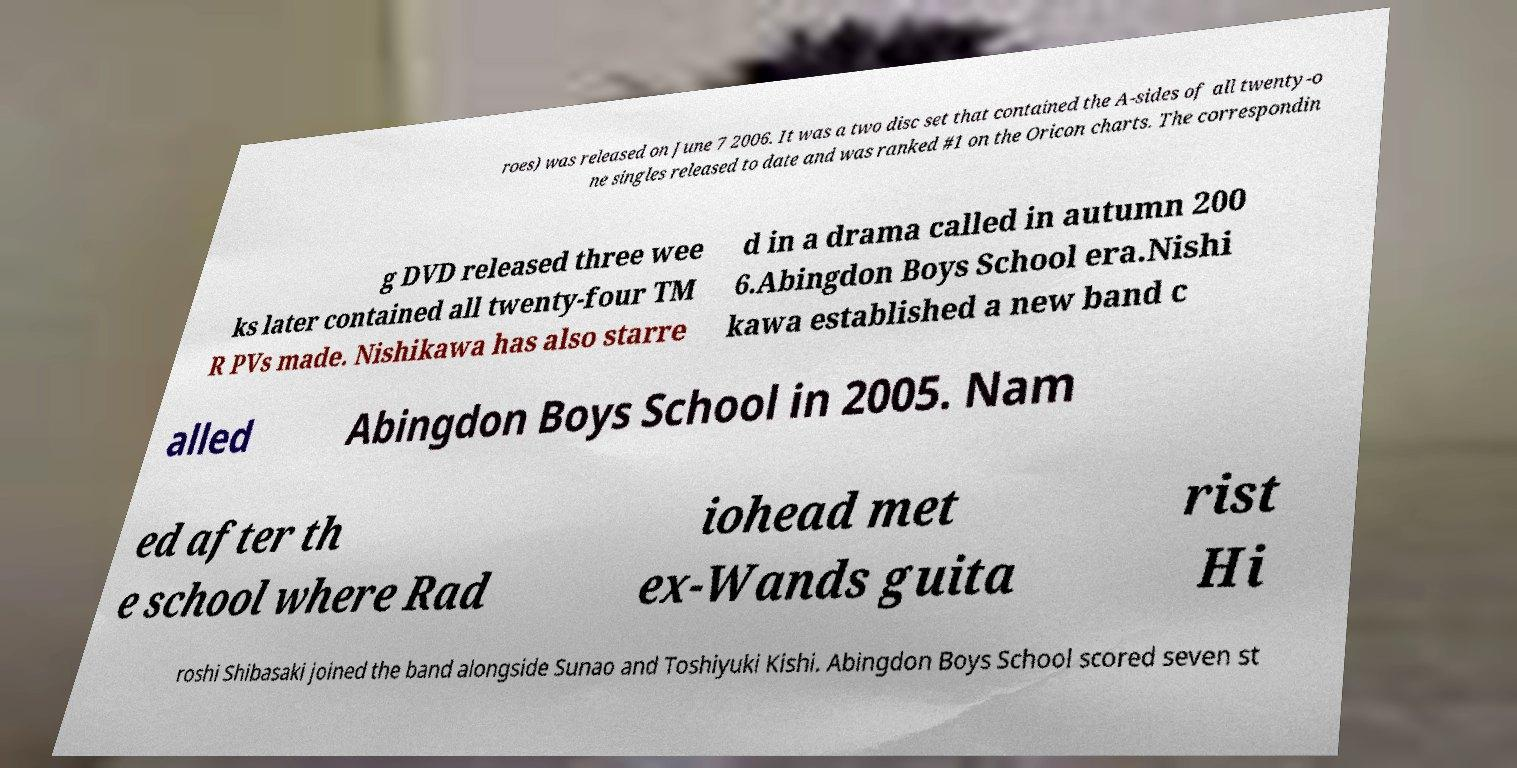What messages or text are displayed in this image? I need them in a readable, typed format. roes) was released on June 7 2006. It was a two disc set that contained the A-sides of all twenty-o ne singles released to date and was ranked #1 on the Oricon charts. The correspondin g DVD released three wee ks later contained all twenty-four TM R PVs made. Nishikawa has also starre d in a drama called in autumn 200 6.Abingdon Boys School era.Nishi kawa established a new band c alled Abingdon Boys School in 2005. Nam ed after th e school where Rad iohead met ex-Wands guita rist Hi roshi Shibasaki joined the band alongside Sunao and Toshiyuki Kishi. Abingdon Boys School scored seven st 